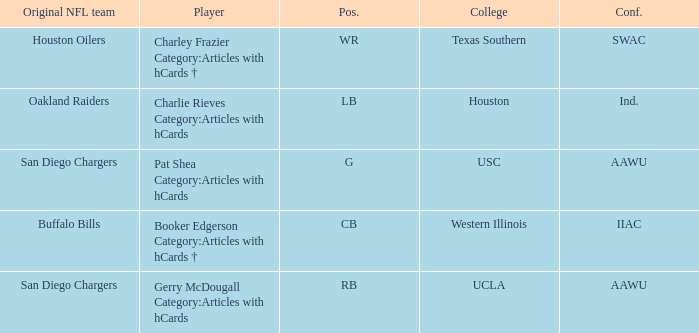What player's original team are the Oakland Raiders? Charlie Rieves Category:Articles with hCards. 